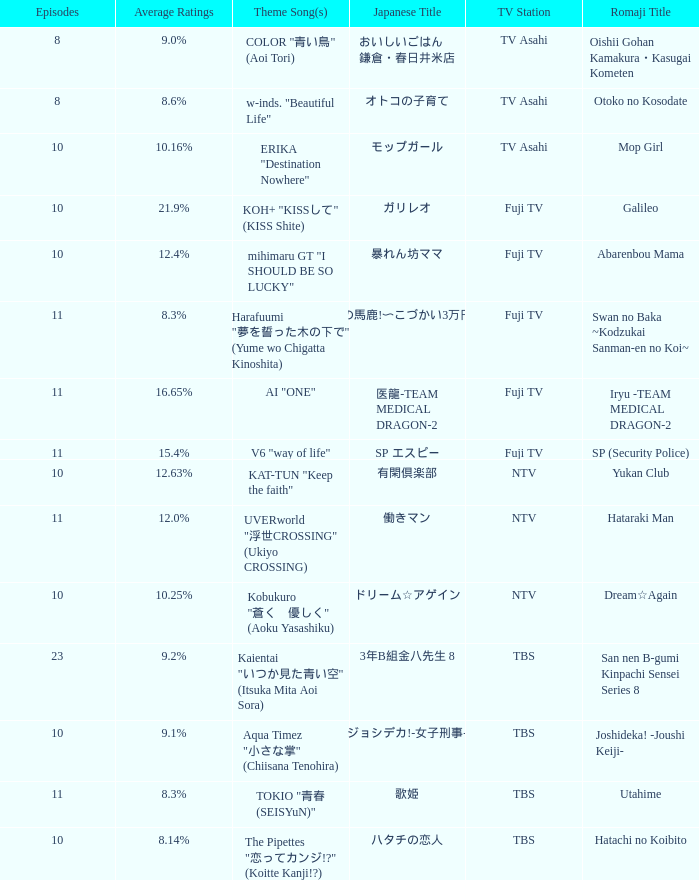What is the main song of the series on fuji tv station with median ratings of 1 AI "ONE". 